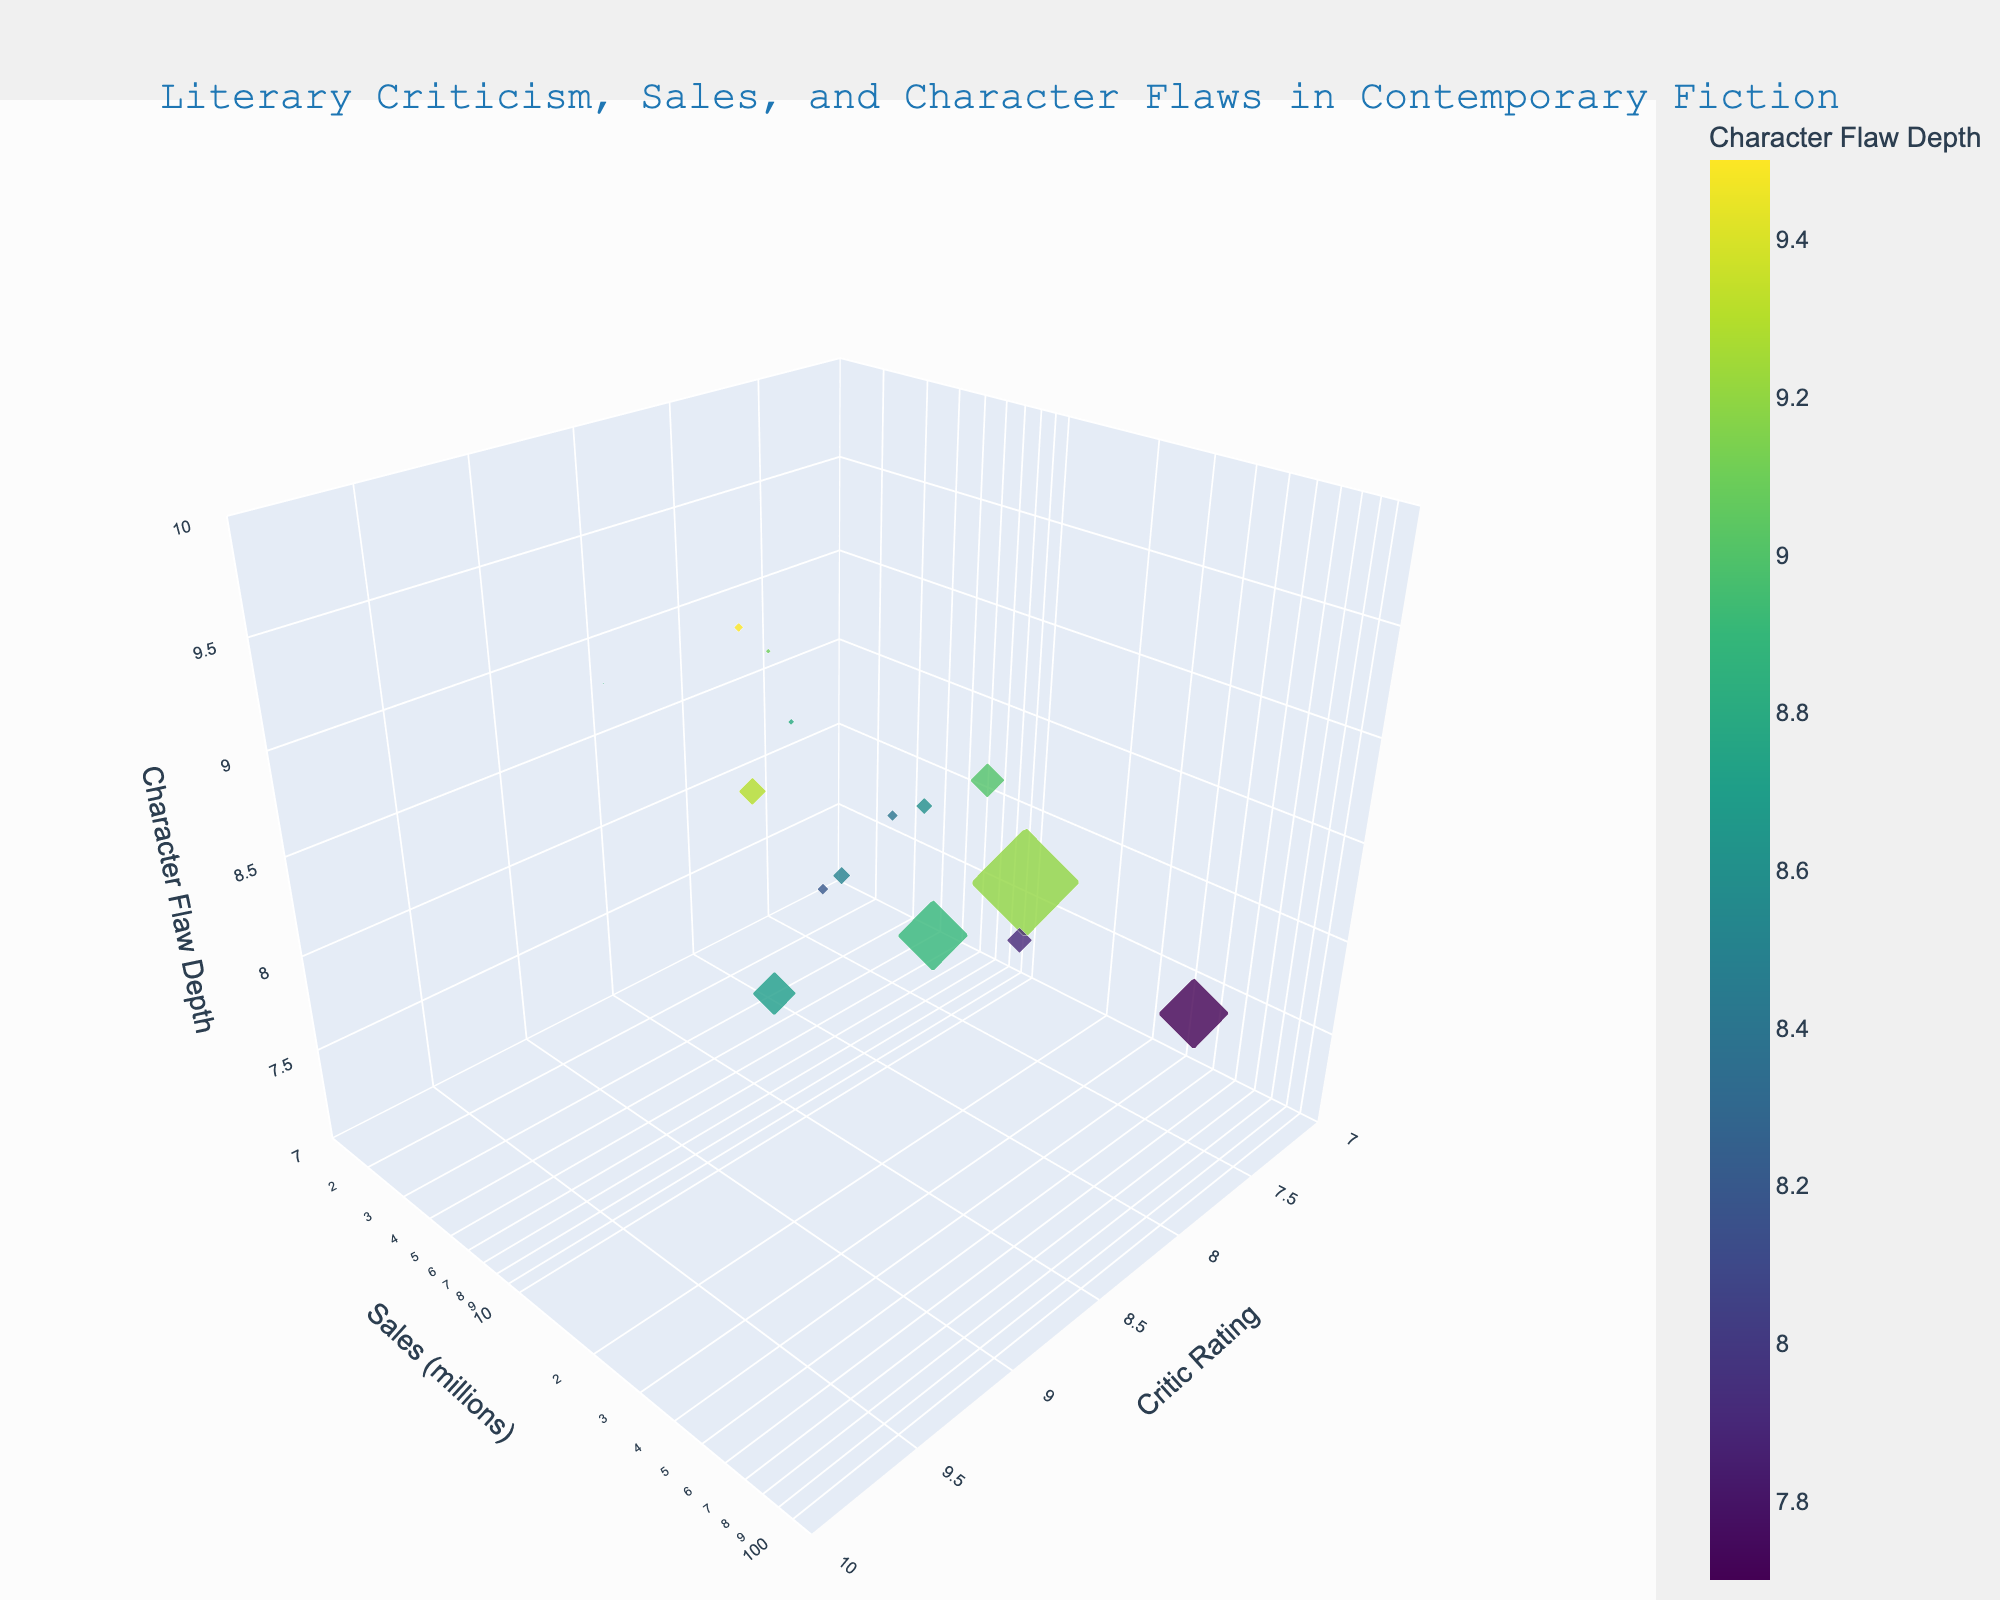What is the title of the plot? The title is placed at the top of the plot and reads "Literary Criticism, Sales, and Character Flaws in Contemporary Fiction."
Answer: Literary Criticism, Sales, and Character Flaws in Contemporary Fiction What axis represents book sales? The y-axis represents book sales. It is labeled 'Sales (millions)' and is positioned vertically in the 3D plot.
Answer: y-axis How many books have a Critic Rating of 9.0 or above? Looking at the x-axis (Critic Rating), we see markers aligned above the 9.0 mark; these are for "The Catcher in the Rye," "The Great Gatsby," "To Kill a Mockingbird," and "1984." A total of 4 books.
Answer: 4 What book has the highest sales? To determine this, look for the marker positioned at the highest point on the y-axis (Sales). "1984" has the highest sales of 100 million.
Answer: 1984 Which book explores the deepest character flaws according to the plot? Look at the z-axis (Character Flaw Depth) and find the marker at the highest point. "Gone Girl" shows the deepest character flaws with a depth of 9.5.
Answer: Gone Girl Does higher book sales correlate with deeper exploration of character flaws based on the plot? By assessing the scatter of markers, there appears to be no clear correlation. Some high-sales books also explore deep character flaws (e.g., "1984"), while others do not (e.g., "The Hunger Games").
Answer: No Which book has a Character Flaw Depth of 8.8 and what are its sales? Find the marker at z=8.8 on the Character Flaw Depth axis. The tooltip reveals "The Road" with sales of 1.5 million.
Answer: The Road, 1.5 million What is the average Critic Rating of the books that sold over 30 million copies? The books are "The Catcher in the Rye" (9.1), "The Kite Runner" (8.3), "To Kill a Mockingbird" (9.5), "The Great Gatsby" (9.3), "1984" (9.0), and "The Hunger Games" (7.5). Calculating (9.1 + 8.3 + 9.5 + 9.3 + 9.0 + 7.5) / 6 gives an average rating of 8.78.
Answer: 8.78 Among books with a Critic Rating above 8.5, which has the lowest sales? Identify markers above 8.5 on the x-axis; "The Road" has the lowest sales with 1.5 million.
Answer: The Road What is the relationship between Sales and Critic Ratings for "The Girl with the Dragon Tattoo"? The marker for "The Girl with the Dragon Tattoo" shows a Critic Rating of 8.1 and sales of 15 million, indicating a moderate rating with moderate sales compared to other books.
Answer: Moderately high sales and rating 